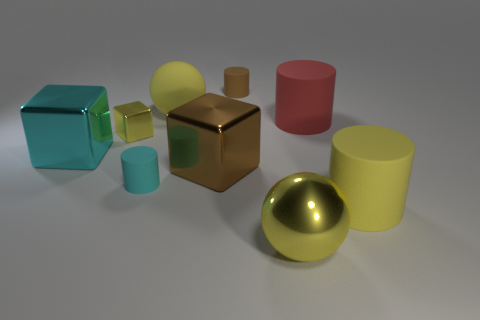How would you describe the lighting in the scene? The lighting in the scene is soft and diffused, producing gentle shadows and subtle highlights on the objects. It appears to be coming from the upper left, given the direction of the shadows, providing an evenly lit environment that allows the colors and materials of the objects to be clearly seen. 